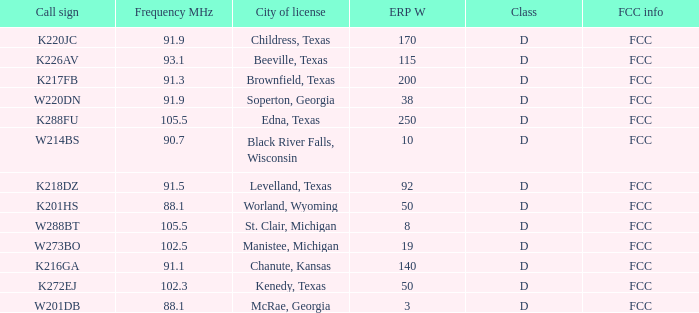What is City of License, when Frequency MHz is less than 102.5? McRae, Georgia, Soperton, Georgia, Chanute, Kansas, Beeville, Texas, Brownfield, Texas, Childress, Texas, Kenedy, Texas, Levelland, Texas, Black River Falls, Wisconsin, Worland, Wyoming. 